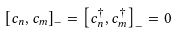<formula> <loc_0><loc_0><loc_500><loc_500>\left [ c _ { n } , c _ { m } \right ] _ { - } = \left [ c _ { n } ^ { \dagger } , c _ { m } ^ { \dagger } \right ] _ { - } = 0</formula> 